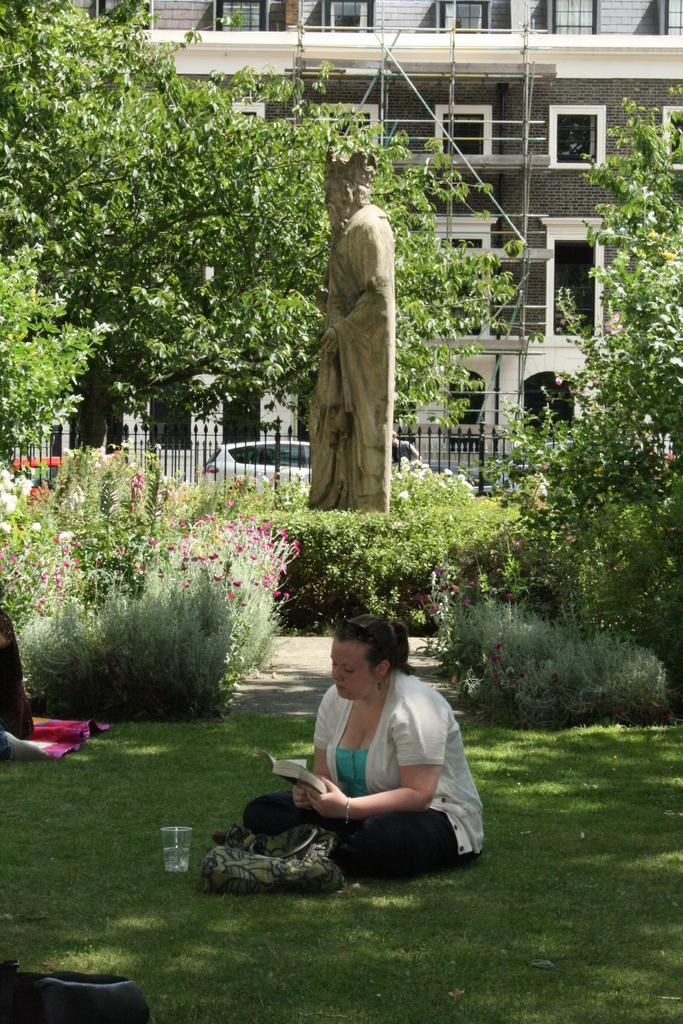Could you give a brief overview of what you see in this image? In this image there is a woman sitting on a grassland, holding a book in her hand, in the background there are plants, trees, statute, railing, car and a building. 